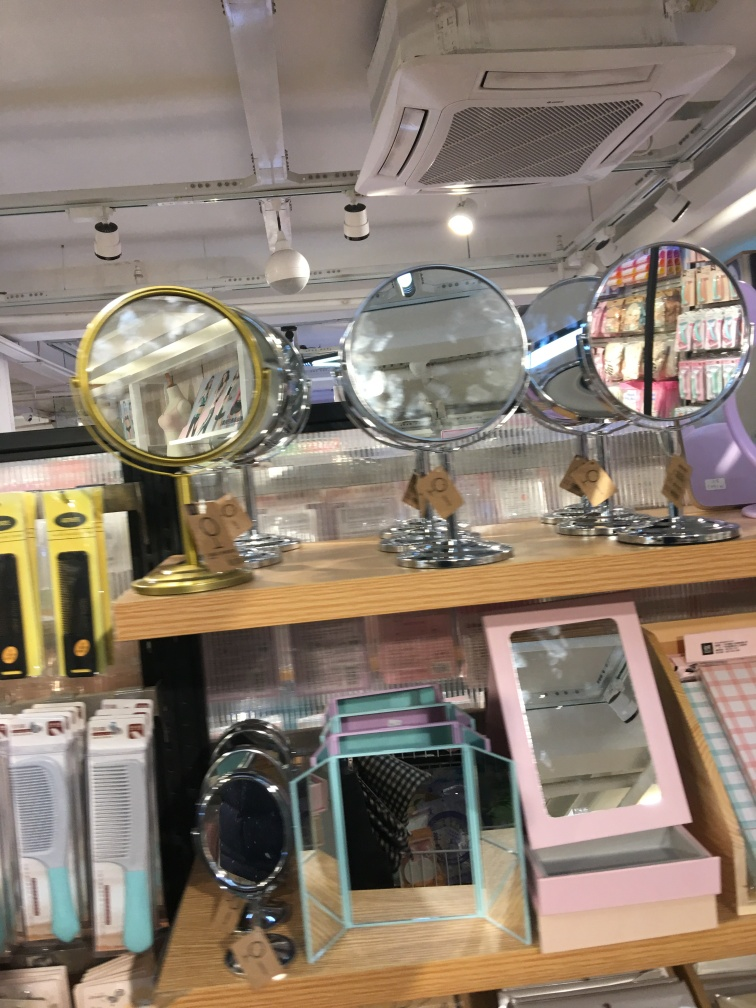What can you infer about the store from the image? From the displayed mirrors and personal care items, it can be inferred that the store likely specializes in beauty and grooming products. The setting appears informal and geared towards self-service. 